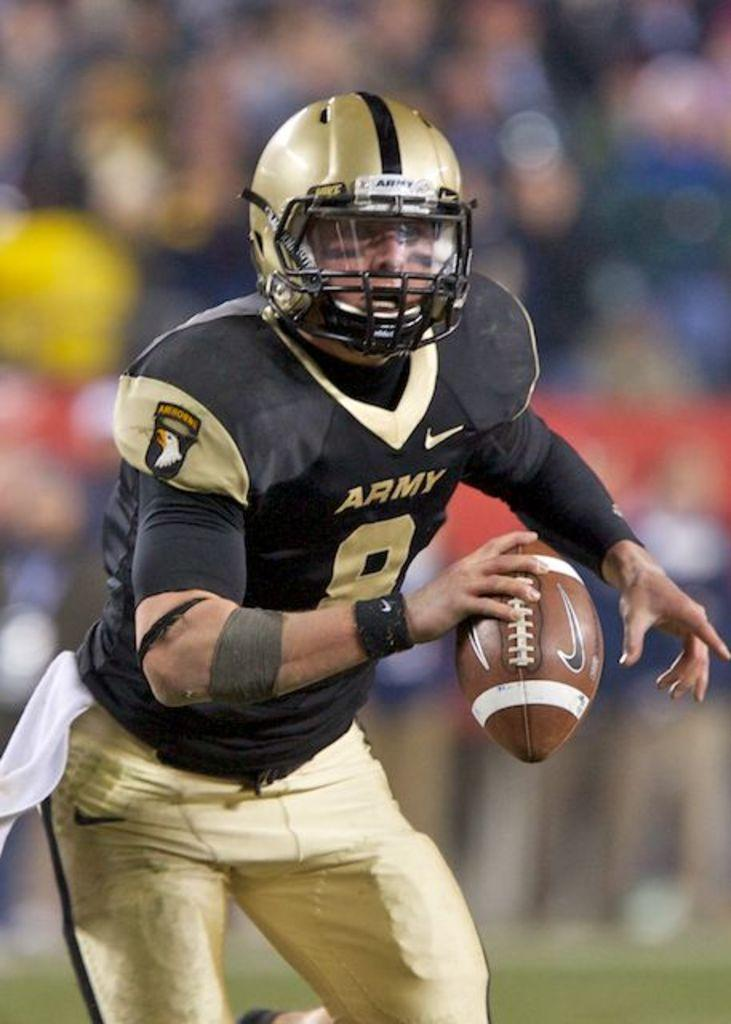What is the main subject of the image? There is a person in the image. What is the person doing in the image? The person is standing. What object is the person holding in their hand? The person is holding a ball in their hand. What protective gear is the person wearing? The person is wearing a helmet. What type of clothing is the person wearing on their lower body? The person is wearing pants. What color are the clothes the person is wearing? The person is wearing black clothes. Can you describe the background of the image? The background of the image is blurred. What type of fish can be seen swimming in the background of the image? There are no fish present in the image; the background is blurred. What is the taste of the ball the person is holding in the image? The image does not provide any information about the taste of the ball, as it is a visual representation and does not convey taste. 